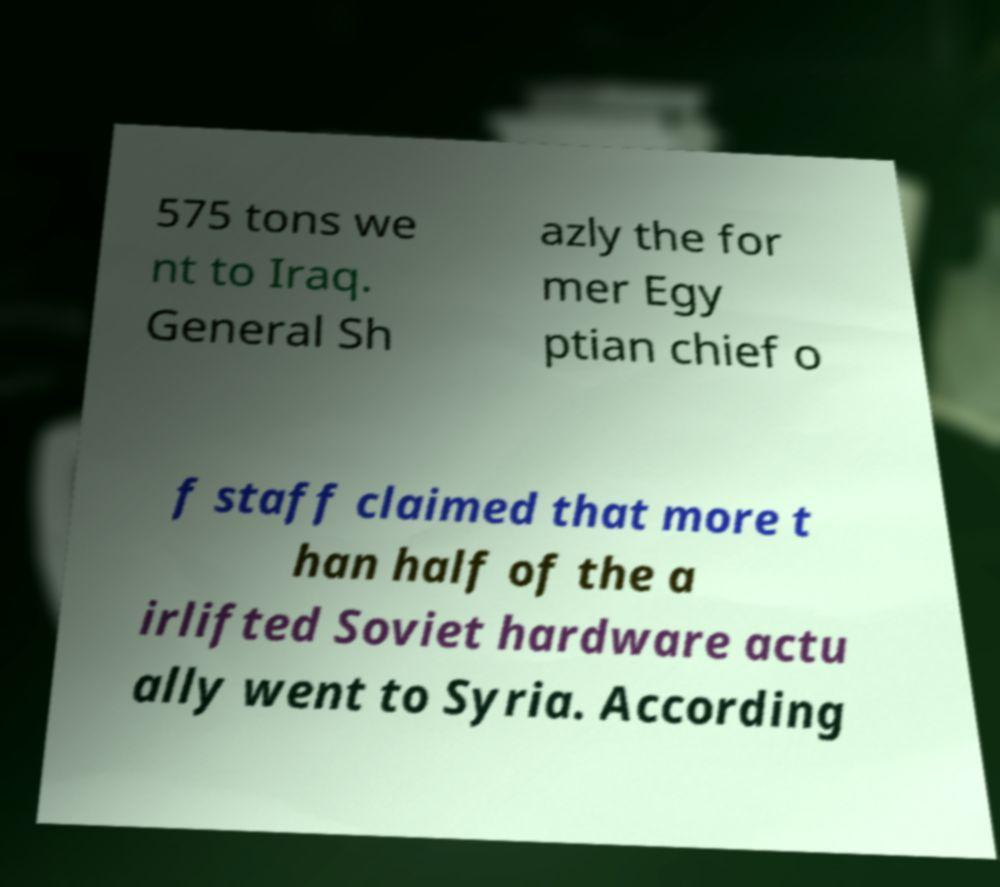Could you extract and type out the text from this image? 575 tons we nt to Iraq. General Sh azly the for mer Egy ptian chief o f staff claimed that more t han half of the a irlifted Soviet hardware actu ally went to Syria. According 